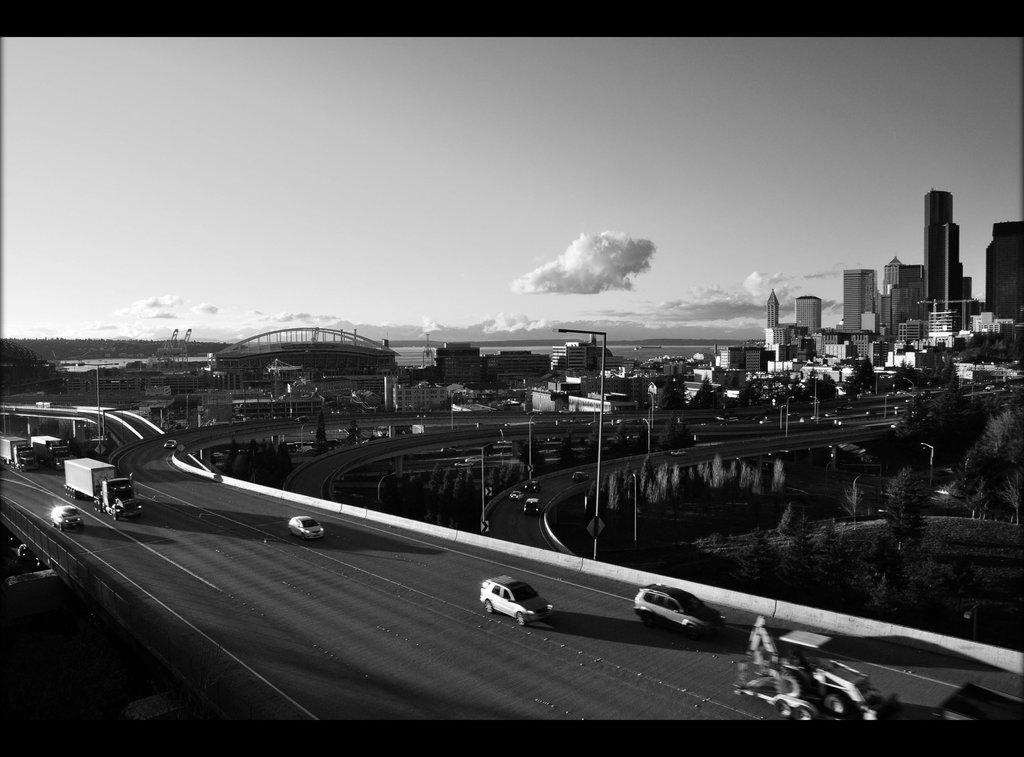Describe this image in one or two sentences. In this picture we can observe a bridge on which there are some vehicles moving. We can observe some poles and buildings. There are some trees. In the background there is a sky with some clouds. This is a black and white image. 